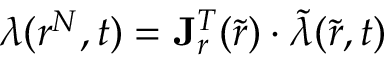<formula> <loc_0><loc_0><loc_500><loc_500>\lambda ( r ^ { N } , t ) = J _ { r } ^ { T } ( \tilde { r } ) \cdot \tilde { \lambda } ( \tilde { r } , t )</formula> 